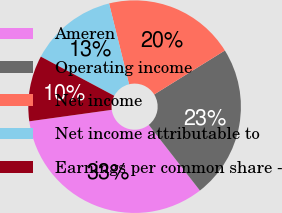Convert chart to OTSL. <chart><loc_0><loc_0><loc_500><loc_500><pie_chart><fcel>Ameren<fcel>Operating income<fcel>Net income<fcel>Net income attributable to<fcel>Earnings per common share -<nl><fcel>33.33%<fcel>23.33%<fcel>20.0%<fcel>13.34%<fcel>10.0%<nl></chart> 